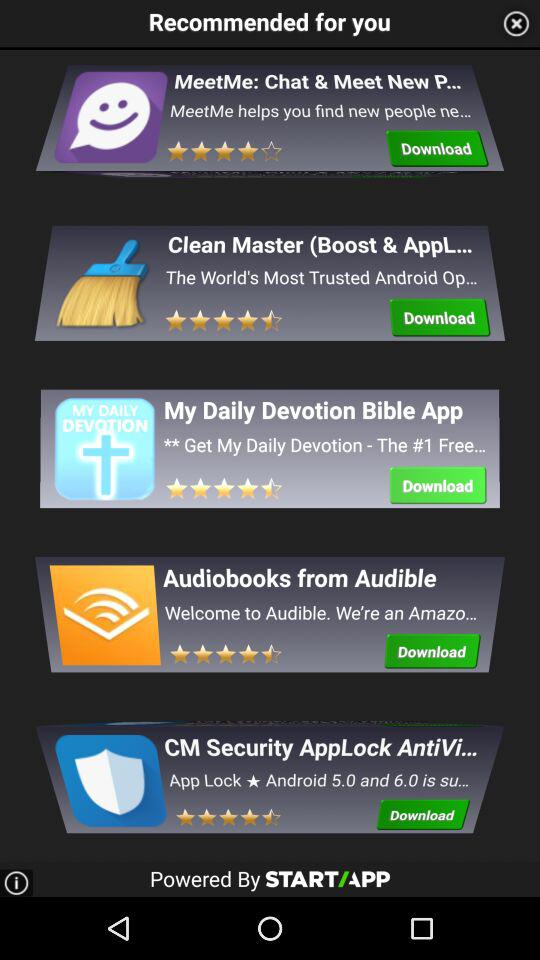What is the rating of Clean Master? The rating is 4.5 stars. 